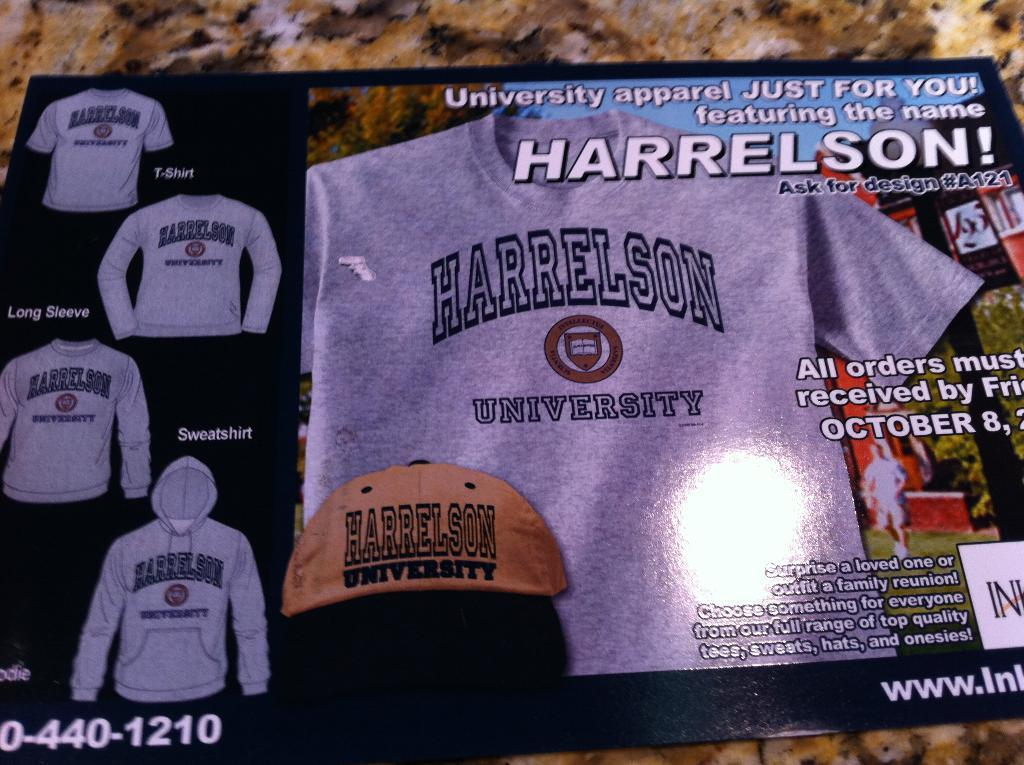<image>
Render a clear and concise summary of the photo. Advertisement for the University of Harrelson to design shirts. 